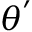Convert formula to latex. <formula><loc_0><loc_0><loc_500><loc_500>{ \theta } ^ { \prime }</formula> 